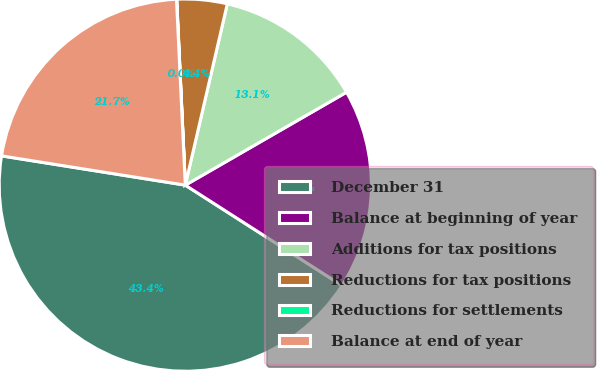Convert chart. <chart><loc_0><loc_0><loc_500><loc_500><pie_chart><fcel>December 31<fcel>Balance at beginning of year<fcel>Additions for tax positions<fcel>Reductions for tax positions<fcel>Reductions for settlements<fcel>Balance at end of year<nl><fcel>43.44%<fcel>17.39%<fcel>13.05%<fcel>4.36%<fcel>0.02%<fcel>21.73%<nl></chart> 